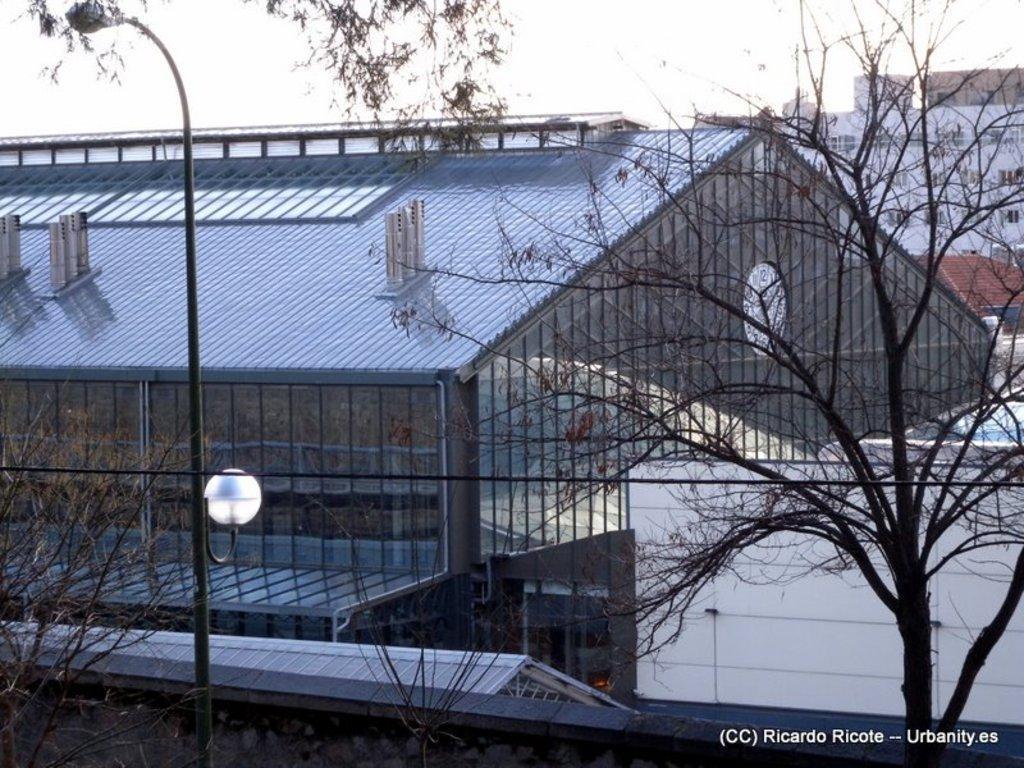How would you summarize this image in a sentence or two? In this image there is a building in the background. At the bottom there is a pole on the ground. On the right side there is a tree. In the background there are buildings. 